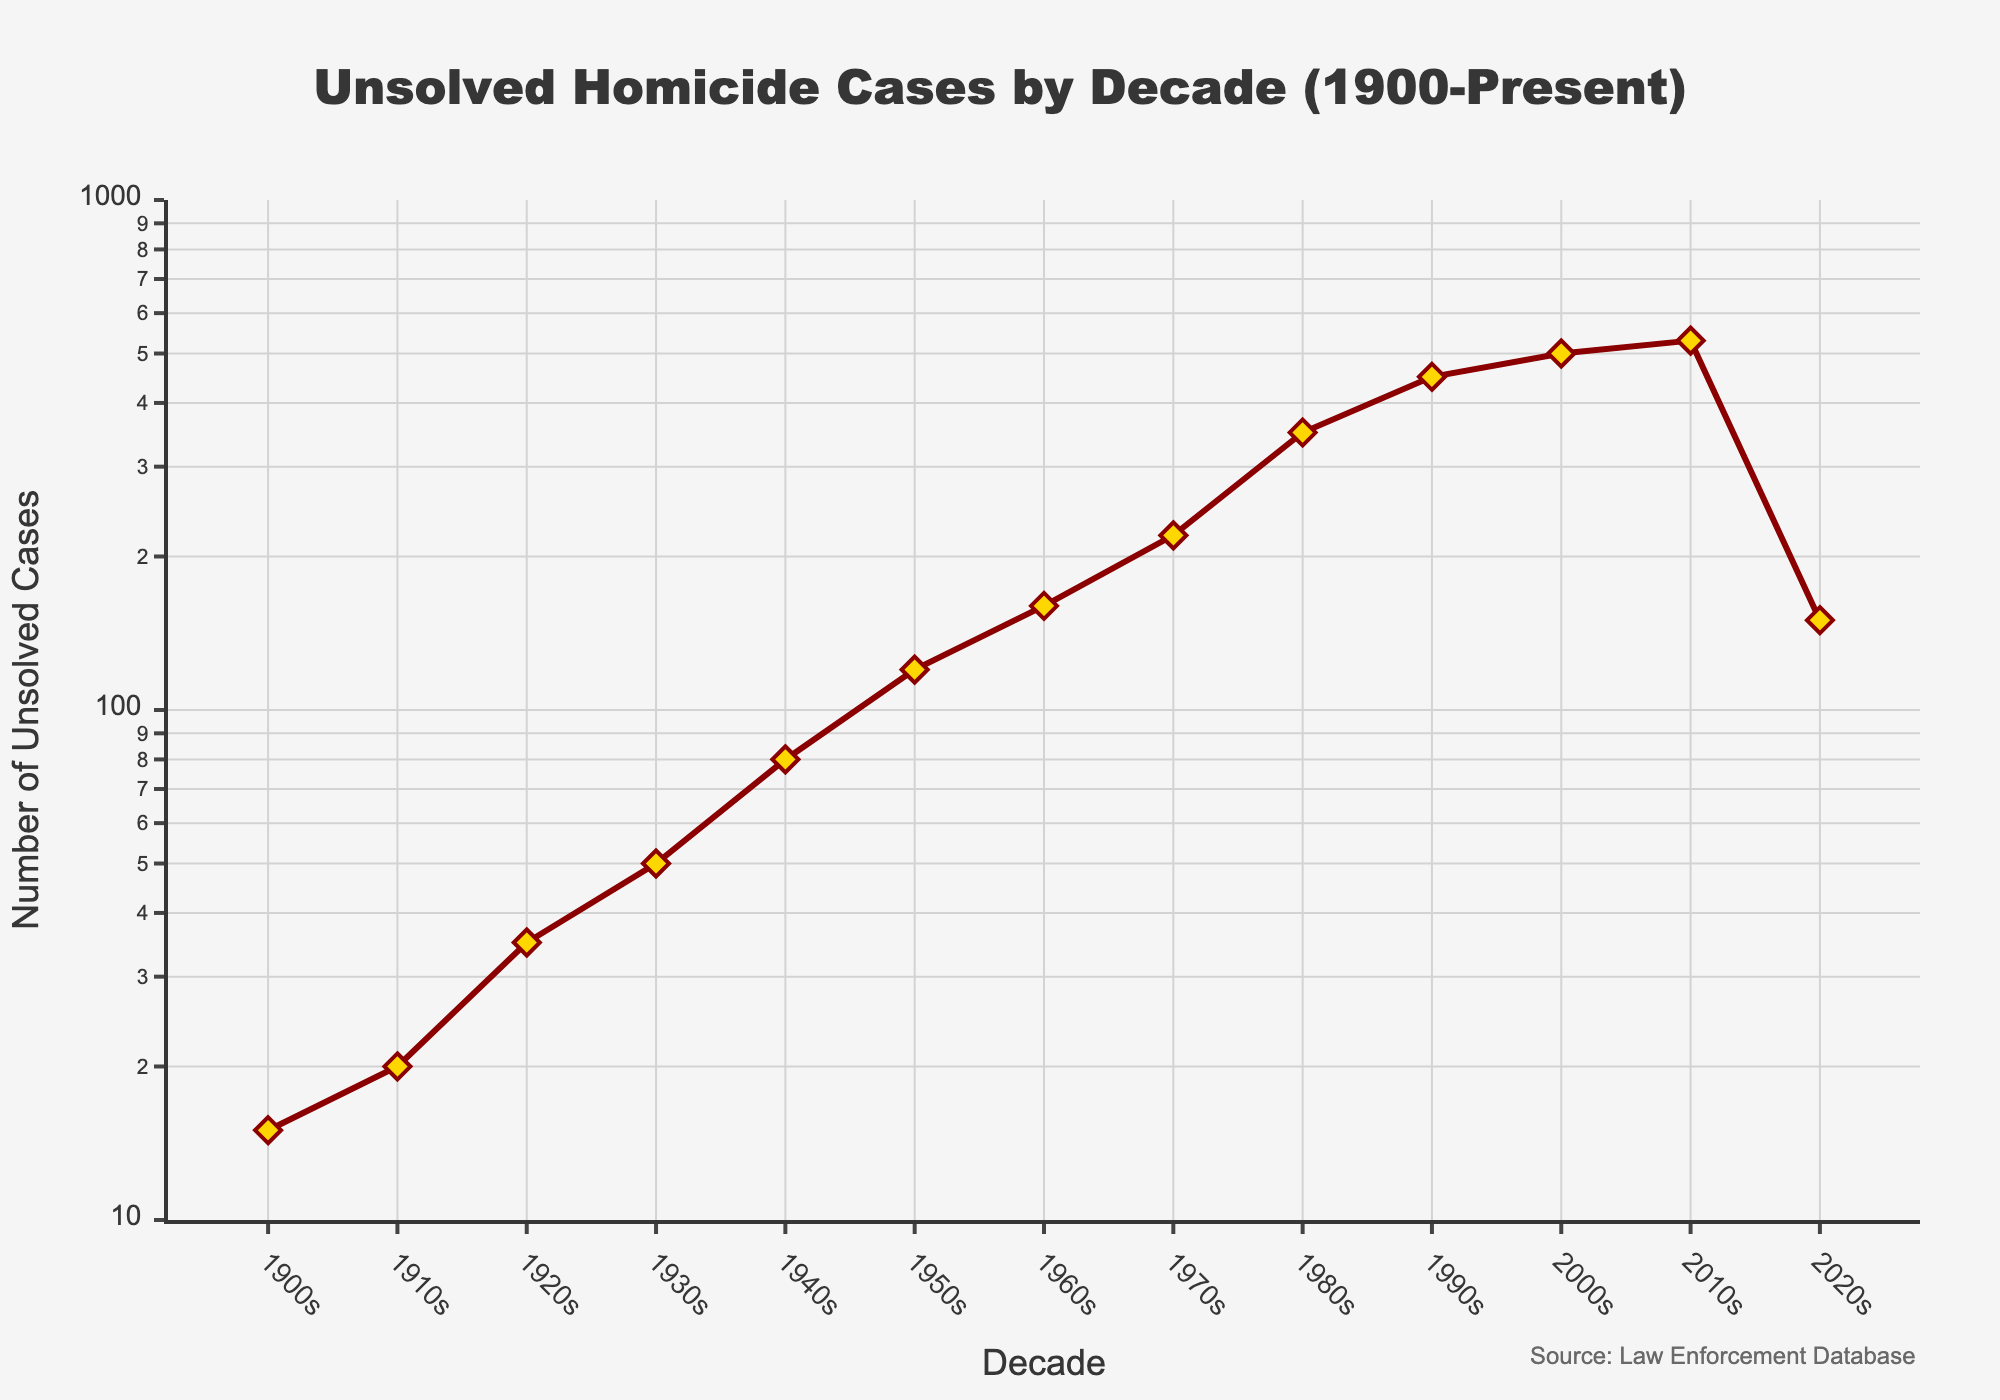How many unsolved homicide cases were recorded in the 2000s? According to the figure, the number of unsolved homicide cases in the 2000s is marked directly on the y-axis opposite the 2000s on the x-axis.
Answer: 500 What trend is observed in the number of unsolved homicide cases from the 1900s to the 2010s? The figure shows a logarithmic increase in the number of unsolved homicide cases from the 1900s to the 2010s, indicating significant growth over the decades.
Answer: Increasing trend In which decade do we see the highest number of unsolved homicide cases? The decade with the highest number of unsolved homicide cases is indicated by the data point positioned highest on the y-axis. In this case, it is the 2010s.
Answer: 2010s What is the approximate rate of increase in unsolved homicide cases between the 1940s and 1960s? Calculate the difference between the cases in the 1960s (160) and the 1940s (80), then divide by the number of decades (2). (160-80) / 2 = 40 cases increase per decade.
Answer: 40 cases per decade How does the number of unsolved cases in the 2020s compare to the 2010s? The number of unsolved cases in the 2020s shows a marked decrease compared to the 2010s. The figure shows 530 in the 2010s and 150 in the 2020s.
Answer: Decrease What is the total number of unsolved homicide cases from the 1900s to the 1920s? Add the cases for 1900s (15), 1910s (20), and 1920s (35). Summing 15 + 20 + 35 gives 70.
Answer: 70 By how much did the number of unsolved cases increase between the 1980s and 1990s? Compute the difference between the 1990s (450) and the 1980s (350). Subtracting 350 from 450 gives 100.
Answer: 100 What kind of scale is used for the y-axis in this figure? The annotations on the y-axis and the description indicate that it employs a logarithmic scale, suitable for visualizing large range data.
Answer: Logarithmic scale Which decade marks a sharp change in the trend of unsolved homicide cases? The most noticeable shift in the trend appears between the 1950s (120) and the 1960s (160), representing a more rapid increase.
Answer: 1950s-1960s What's the difference in the number of unsolved cases between the starting and the ending point of the time series? Subtract the cases in the 2020s (150) from the cases in the 1900s (15). The difference is 15 - 150 = -135, showing an increase of 135 unsolved cases.
Answer: 135 